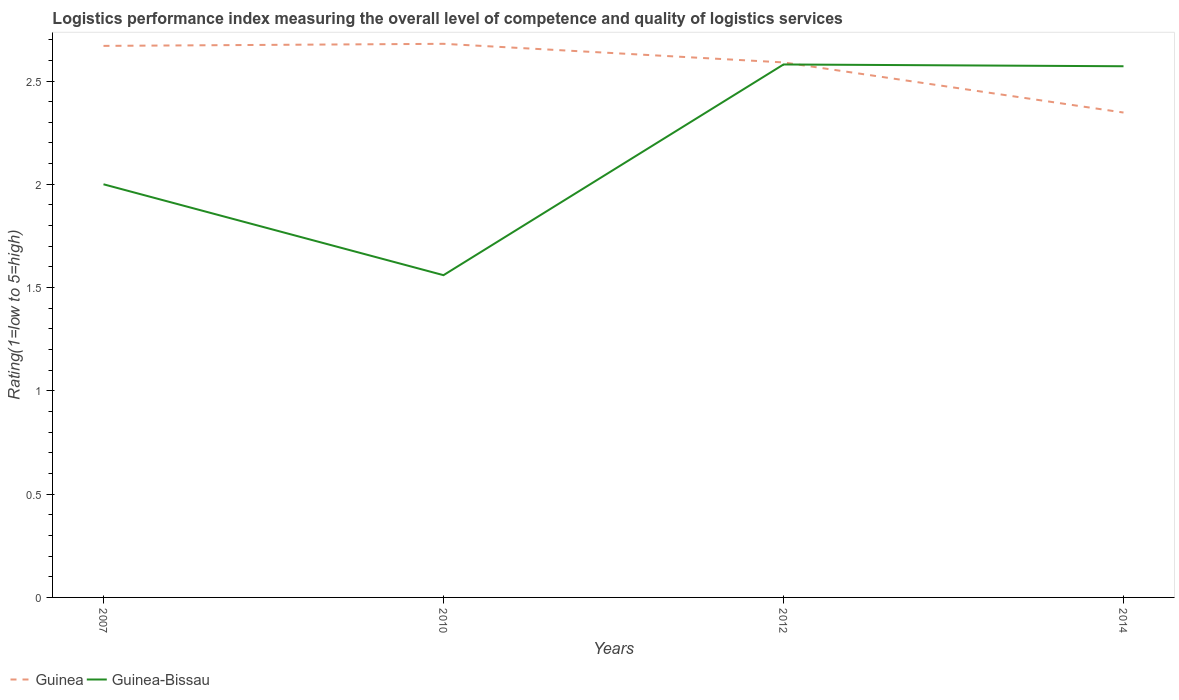Does the line corresponding to Guinea intersect with the line corresponding to Guinea-Bissau?
Offer a terse response. Yes. Is the number of lines equal to the number of legend labels?
Keep it short and to the point. Yes. Across all years, what is the maximum Logistic performance index in Guinea?
Make the answer very short. 2.35. What is the total Logistic performance index in Guinea in the graph?
Offer a very short reply. 0.33. What is the difference between the highest and the second highest Logistic performance index in Guinea?
Ensure brevity in your answer.  0.33. Is the Logistic performance index in Guinea-Bissau strictly greater than the Logistic performance index in Guinea over the years?
Provide a succinct answer. No. Does the graph contain any zero values?
Your response must be concise. No. Does the graph contain grids?
Your response must be concise. No. How are the legend labels stacked?
Offer a terse response. Horizontal. What is the title of the graph?
Offer a terse response. Logistics performance index measuring the overall level of competence and quality of logistics services. Does "Portugal" appear as one of the legend labels in the graph?
Provide a succinct answer. No. What is the label or title of the X-axis?
Ensure brevity in your answer.  Years. What is the label or title of the Y-axis?
Provide a succinct answer. Rating(1=low to 5=high). What is the Rating(1=low to 5=high) of Guinea in 2007?
Give a very brief answer. 2.67. What is the Rating(1=low to 5=high) in Guinea-Bissau in 2007?
Ensure brevity in your answer.  2. What is the Rating(1=low to 5=high) of Guinea in 2010?
Your answer should be compact. 2.68. What is the Rating(1=low to 5=high) of Guinea-Bissau in 2010?
Keep it short and to the point. 1.56. What is the Rating(1=low to 5=high) of Guinea in 2012?
Your answer should be compact. 2.59. What is the Rating(1=low to 5=high) in Guinea-Bissau in 2012?
Offer a very short reply. 2.58. What is the Rating(1=low to 5=high) in Guinea in 2014?
Your response must be concise. 2.35. What is the Rating(1=low to 5=high) in Guinea-Bissau in 2014?
Keep it short and to the point. 2.57. Across all years, what is the maximum Rating(1=low to 5=high) of Guinea?
Provide a succinct answer. 2.68. Across all years, what is the maximum Rating(1=low to 5=high) in Guinea-Bissau?
Provide a succinct answer. 2.58. Across all years, what is the minimum Rating(1=low to 5=high) in Guinea?
Provide a short and direct response. 2.35. Across all years, what is the minimum Rating(1=low to 5=high) of Guinea-Bissau?
Your response must be concise. 1.56. What is the total Rating(1=low to 5=high) of Guinea in the graph?
Offer a terse response. 10.29. What is the total Rating(1=low to 5=high) of Guinea-Bissau in the graph?
Provide a succinct answer. 8.71. What is the difference between the Rating(1=low to 5=high) in Guinea in 2007 and that in 2010?
Ensure brevity in your answer.  -0.01. What is the difference between the Rating(1=low to 5=high) of Guinea-Bissau in 2007 and that in 2010?
Your response must be concise. 0.44. What is the difference between the Rating(1=low to 5=high) of Guinea in 2007 and that in 2012?
Your response must be concise. 0.08. What is the difference between the Rating(1=low to 5=high) in Guinea-Bissau in 2007 and that in 2012?
Offer a terse response. -0.58. What is the difference between the Rating(1=low to 5=high) in Guinea in 2007 and that in 2014?
Ensure brevity in your answer.  0.32. What is the difference between the Rating(1=low to 5=high) of Guinea-Bissau in 2007 and that in 2014?
Ensure brevity in your answer.  -0.57. What is the difference between the Rating(1=low to 5=high) in Guinea in 2010 and that in 2012?
Provide a short and direct response. 0.09. What is the difference between the Rating(1=low to 5=high) of Guinea-Bissau in 2010 and that in 2012?
Offer a terse response. -1.02. What is the difference between the Rating(1=low to 5=high) of Guinea in 2010 and that in 2014?
Your response must be concise. 0.33. What is the difference between the Rating(1=low to 5=high) in Guinea-Bissau in 2010 and that in 2014?
Your response must be concise. -1.01. What is the difference between the Rating(1=low to 5=high) in Guinea in 2012 and that in 2014?
Offer a very short reply. 0.24. What is the difference between the Rating(1=low to 5=high) in Guinea-Bissau in 2012 and that in 2014?
Keep it short and to the point. 0.01. What is the difference between the Rating(1=low to 5=high) in Guinea in 2007 and the Rating(1=low to 5=high) in Guinea-Bissau in 2010?
Offer a very short reply. 1.11. What is the difference between the Rating(1=low to 5=high) of Guinea in 2007 and the Rating(1=low to 5=high) of Guinea-Bissau in 2012?
Make the answer very short. 0.09. What is the difference between the Rating(1=low to 5=high) of Guinea in 2007 and the Rating(1=low to 5=high) of Guinea-Bissau in 2014?
Offer a terse response. 0.1. What is the difference between the Rating(1=low to 5=high) in Guinea in 2010 and the Rating(1=low to 5=high) in Guinea-Bissau in 2012?
Your answer should be compact. 0.1. What is the difference between the Rating(1=low to 5=high) in Guinea in 2010 and the Rating(1=low to 5=high) in Guinea-Bissau in 2014?
Your answer should be very brief. 0.11. What is the difference between the Rating(1=low to 5=high) of Guinea in 2012 and the Rating(1=low to 5=high) of Guinea-Bissau in 2014?
Give a very brief answer. 0.02. What is the average Rating(1=low to 5=high) in Guinea per year?
Offer a terse response. 2.57. What is the average Rating(1=low to 5=high) in Guinea-Bissau per year?
Make the answer very short. 2.18. In the year 2007, what is the difference between the Rating(1=low to 5=high) in Guinea and Rating(1=low to 5=high) in Guinea-Bissau?
Your answer should be very brief. 0.67. In the year 2010, what is the difference between the Rating(1=low to 5=high) in Guinea and Rating(1=low to 5=high) in Guinea-Bissau?
Provide a short and direct response. 1.12. In the year 2014, what is the difference between the Rating(1=low to 5=high) in Guinea and Rating(1=low to 5=high) in Guinea-Bissau?
Your answer should be very brief. -0.22. What is the ratio of the Rating(1=low to 5=high) of Guinea-Bissau in 2007 to that in 2010?
Your response must be concise. 1.28. What is the ratio of the Rating(1=low to 5=high) in Guinea in 2007 to that in 2012?
Offer a very short reply. 1.03. What is the ratio of the Rating(1=low to 5=high) of Guinea-Bissau in 2007 to that in 2012?
Offer a terse response. 0.78. What is the ratio of the Rating(1=low to 5=high) in Guinea in 2007 to that in 2014?
Keep it short and to the point. 1.14. What is the ratio of the Rating(1=low to 5=high) in Guinea-Bissau in 2007 to that in 2014?
Offer a terse response. 0.78. What is the ratio of the Rating(1=low to 5=high) of Guinea in 2010 to that in 2012?
Your answer should be very brief. 1.03. What is the ratio of the Rating(1=low to 5=high) of Guinea-Bissau in 2010 to that in 2012?
Your answer should be very brief. 0.6. What is the ratio of the Rating(1=low to 5=high) in Guinea in 2010 to that in 2014?
Offer a terse response. 1.14. What is the ratio of the Rating(1=low to 5=high) in Guinea-Bissau in 2010 to that in 2014?
Give a very brief answer. 0.61. What is the ratio of the Rating(1=low to 5=high) in Guinea in 2012 to that in 2014?
Keep it short and to the point. 1.1. What is the difference between the highest and the second highest Rating(1=low to 5=high) in Guinea?
Ensure brevity in your answer.  0.01. What is the difference between the highest and the second highest Rating(1=low to 5=high) of Guinea-Bissau?
Your response must be concise. 0.01. What is the difference between the highest and the lowest Rating(1=low to 5=high) of Guinea?
Ensure brevity in your answer.  0.33. What is the difference between the highest and the lowest Rating(1=low to 5=high) of Guinea-Bissau?
Your answer should be very brief. 1.02. 